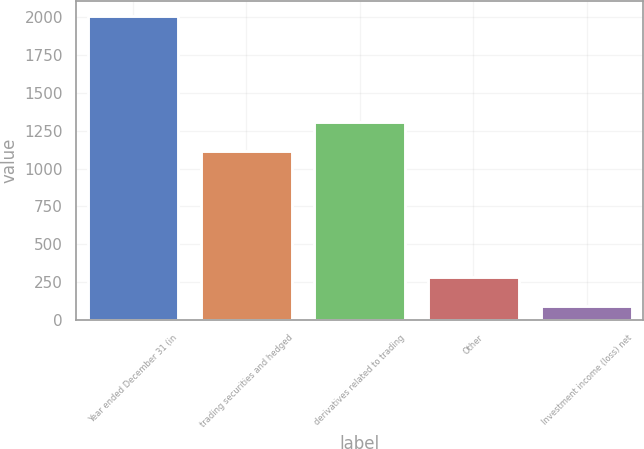<chart> <loc_0><loc_0><loc_500><loc_500><bar_chart><fcel>Year ended December 31 (in<fcel>trading securities and hedged<fcel>derivatives related to trading<fcel>Other<fcel>Investment income (loss) net<nl><fcel>2008<fcel>1117<fcel>1308.9<fcel>280.9<fcel>89<nl></chart> 